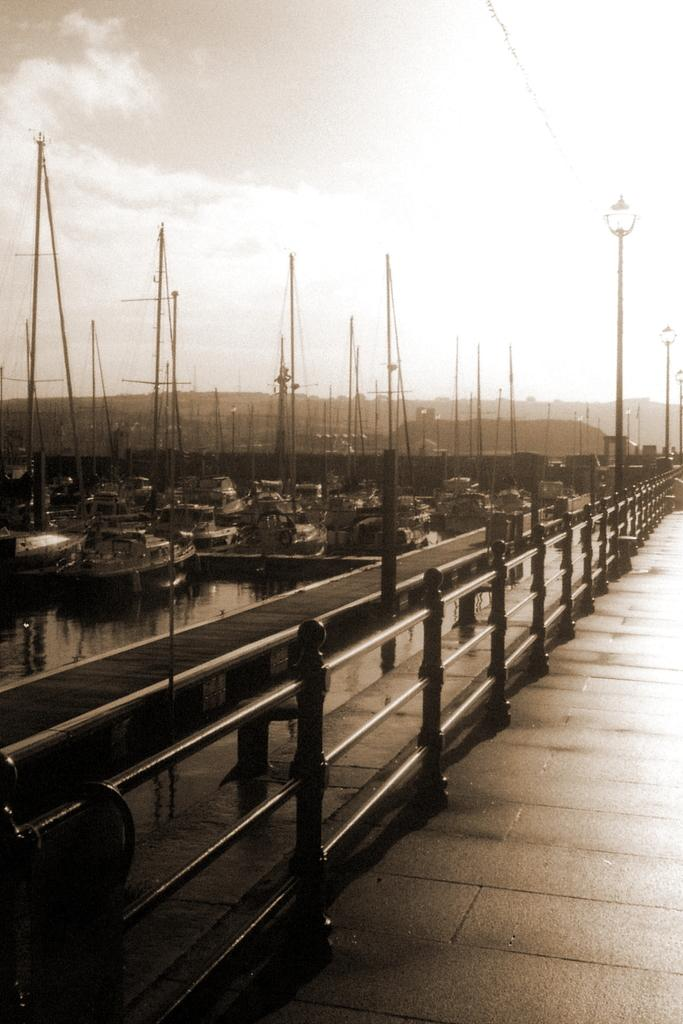What type of structure can be seen in the image? There is a bridge in the image. What other structures are present in the image? There is a wooden pier and poles in the image. Are there any artificial light sources in the image? Yes, there are lights in the image. What type of vehicles can be seen in the image? There are boats on the water in the image. What can be seen in the background of the image? The sky is visible in the background of the image. What type of owl can be seen perched on the bridge in the image? There is no owl present in the image; it only features a bridge, wooden pier, poles, lights, boats, and the sky. What time of day is it in the image, given the presence of a vest? There is no mention of a vest in the image, and the time of day cannot be determined from the information provided. 